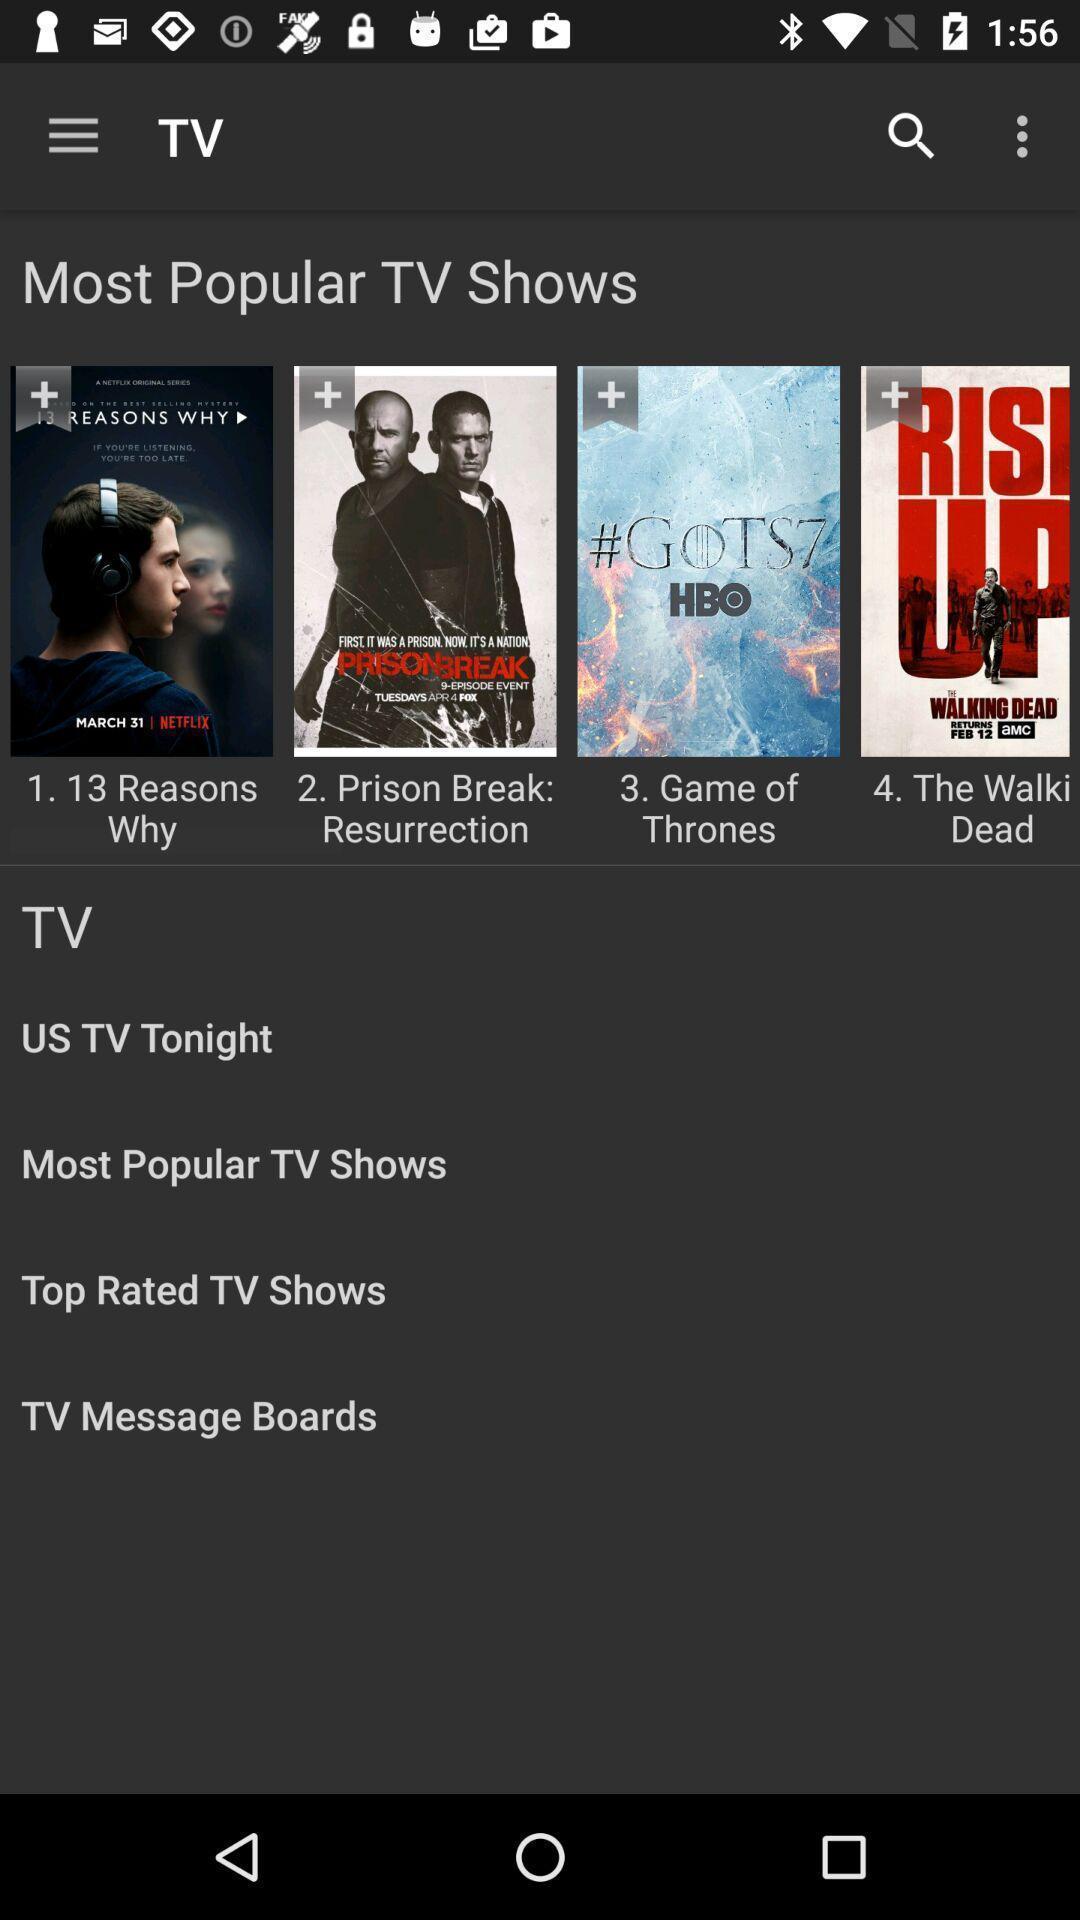Provide a description of this screenshot. Page for the movies application and the posters. 